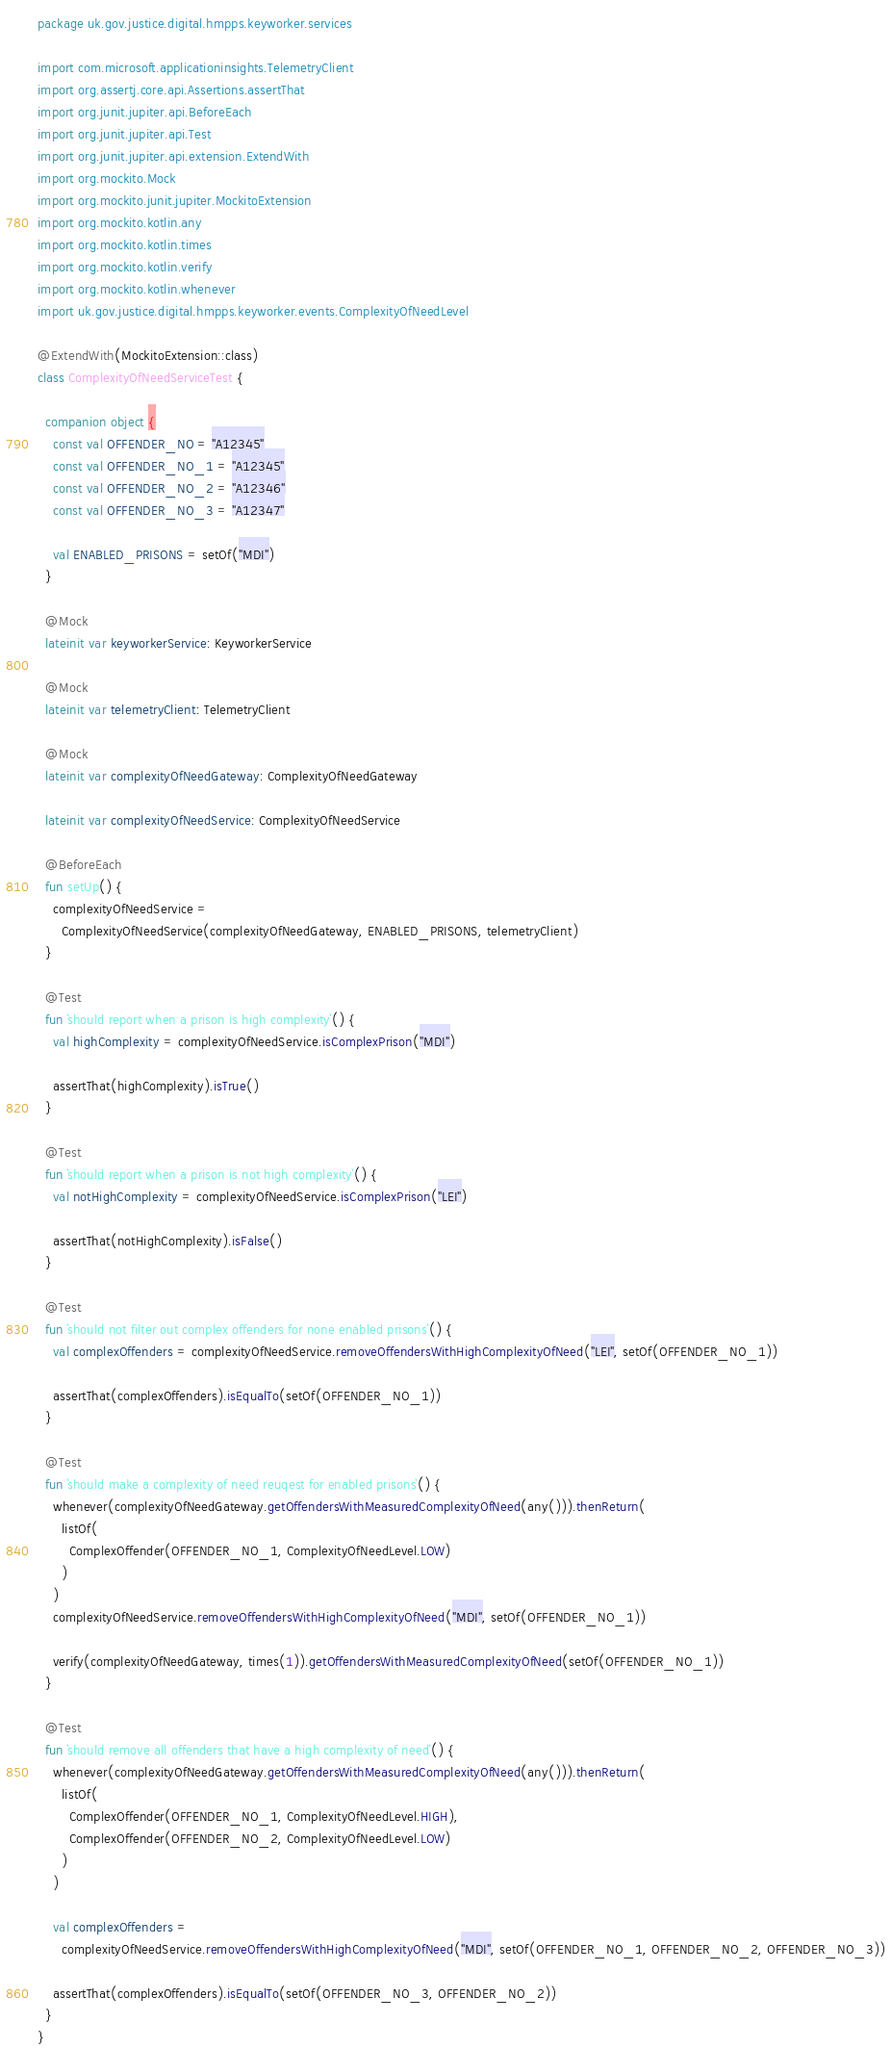Convert code to text. <code><loc_0><loc_0><loc_500><loc_500><_Kotlin_>package uk.gov.justice.digital.hmpps.keyworker.services

import com.microsoft.applicationinsights.TelemetryClient
import org.assertj.core.api.Assertions.assertThat
import org.junit.jupiter.api.BeforeEach
import org.junit.jupiter.api.Test
import org.junit.jupiter.api.extension.ExtendWith
import org.mockito.Mock
import org.mockito.junit.jupiter.MockitoExtension
import org.mockito.kotlin.any
import org.mockito.kotlin.times
import org.mockito.kotlin.verify
import org.mockito.kotlin.whenever
import uk.gov.justice.digital.hmpps.keyworker.events.ComplexityOfNeedLevel

@ExtendWith(MockitoExtension::class)
class ComplexityOfNeedServiceTest {

  companion object {
    const val OFFENDER_NO = "A12345"
    const val OFFENDER_NO_1 = "A12345"
    const val OFFENDER_NO_2 = "A12346"
    const val OFFENDER_NO_3 = "A12347"

    val ENABLED_PRISONS = setOf("MDI")
  }

  @Mock
  lateinit var keyworkerService: KeyworkerService

  @Mock
  lateinit var telemetryClient: TelemetryClient

  @Mock
  lateinit var complexityOfNeedGateway: ComplexityOfNeedGateway

  lateinit var complexityOfNeedService: ComplexityOfNeedService

  @BeforeEach
  fun setUp() {
    complexityOfNeedService =
      ComplexityOfNeedService(complexityOfNeedGateway, ENABLED_PRISONS, telemetryClient)
  }

  @Test
  fun `should report when a prison is high complexity`() {
    val highComplexity = complexityOfNeedService.isComplexPrison("MDI")

    assertThat(highComplexity).isTrue()
  }

  @Test
  fun `should report when a prison is not high complexity`() {
    val notHighComplexity = complexityOfNeedService.isComplexPrison("LEI")

    assertThat(notHighComplexity).isFalse()
  }

  @Test
  fun `should not filter out complex offenders for none enabled prisons`() {
    val complexOffenders = complexityOfNeedService.removeOffendersWithHighComplexityOfNeed("LEI", setOf(OFFENDER_NO_1))

    assertThat(complexOffenders).isEqualTo(setOf(OFFENDER_NO_1))
  }

  @Test
  fun `should make a complexity of need reuqest for enabled prisons`() {
    whenever(complexityOfNeedGateway.getOffendersWithMeasuredComplexityOfNeed(any())).thenReturn(
      listOf(
        ComplexOffender(OFFENDER_NO_1, ComplexityOfNeedLevel.LOW)
      )
    )
    complexityOfNeedService.removeOffendersWithHighComplexityOfNeed("MDI", setOf(OFFENDER_NO_1))

    verify(complexityOfNeedGateway, times(1)).getOffendersWithMeasuredComplexityOfNeed(setOf(OFFENDER_NO_1))
  }

  @Test
  fun `should remove all offenders that have a high complexity of need`() {
    whenever(complexityOfNeedGateway.getOffendersWithMeasuredComplexityOfNeed(any())).thenReturn(
      listOf(
        ComplexOffender(OFFENDER_NO_1, ComplexityOfNeedLevel.HIGH),
        ComplexOffender(OFFENDER_NO_2, ComplexityOfNeedLevel.LOW)
      )
    )

    val complexOffenders =
      complexityOfNeedService.removeOffendersWithHighComplexityOfNeed("MDI", setOf(OFFENDER_NO_1, OFFENDER_NO_2, OFFENDER_NO_3))

    assertThat(complexOffenders).isEqualTo(setOf(OFFENDER_NO_3, OFFENDER_NO_2))
  }
}
</code> 